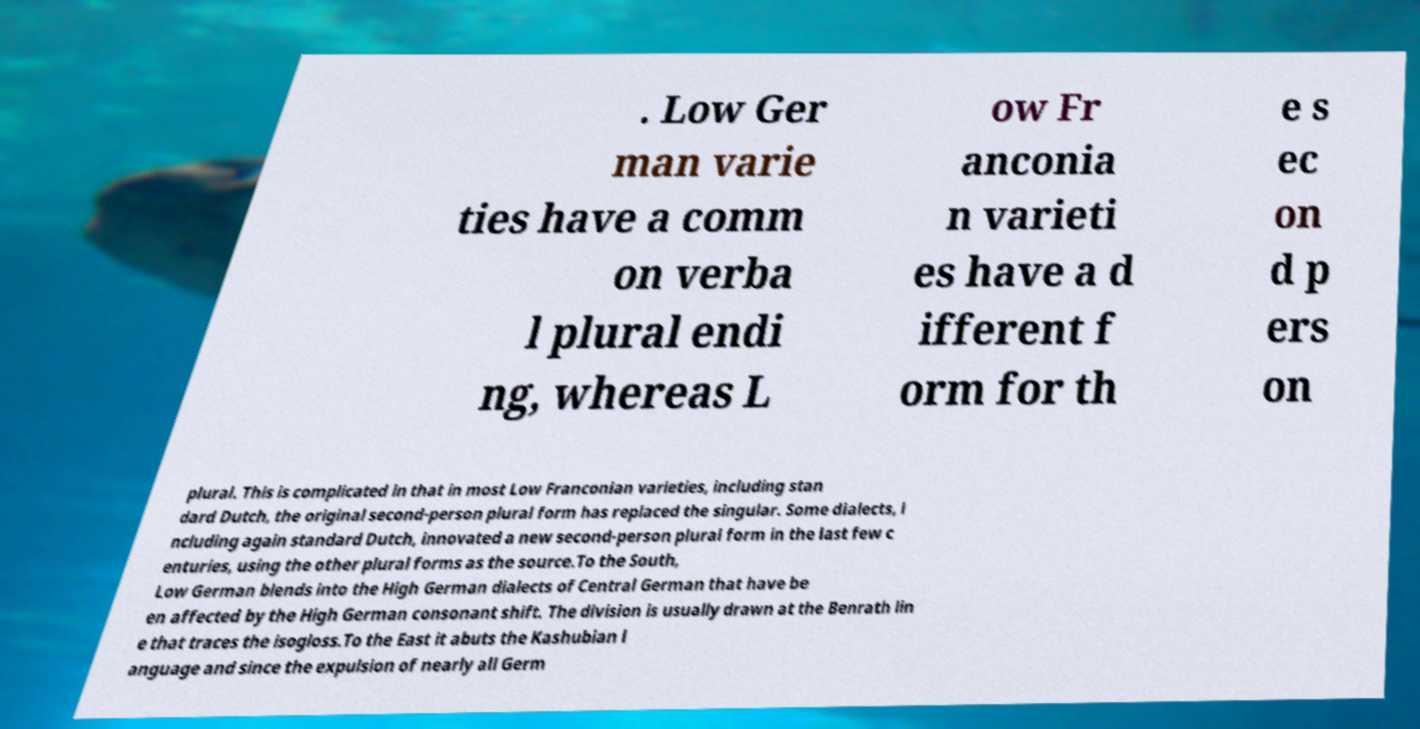There's text embedded in this image that I need extracted. Can you transcribe it verbatim? . Low Ger man varie ties have a comm on verba l plural endi ng, whereas L ow Fr anconia n varieti es have a d ifferent f orm for th e s ec on d p ers on plural. This is complicated in that in most Low Franconian varieties, including stan dard Dutch, the original second-person plural form has replaced the singular. Some dialects, i ncluding again standard Dutch, innovated a new second-person plural form in the last few c enturies, using the other plural forms as the source.To the South, Low German blends into the High German dialects of Central German that have be en affected by the High German consonant shift. The division is usually drawn at the Benrath lin e that traces the isogloss.To the East it abuts the Kashubian l anguage and since the expulsion of nearly all Germ 